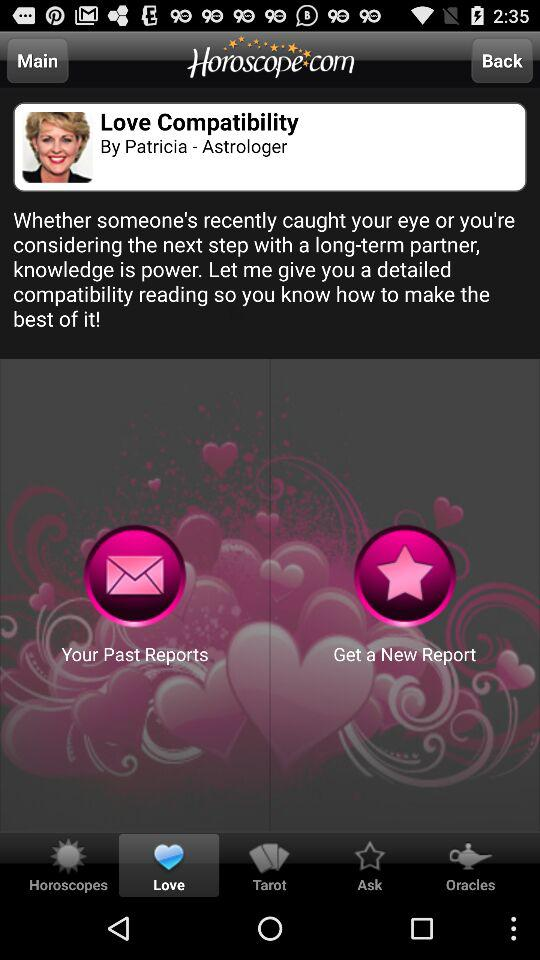Which tab has been selected? The tab that has been selected is "Love". 